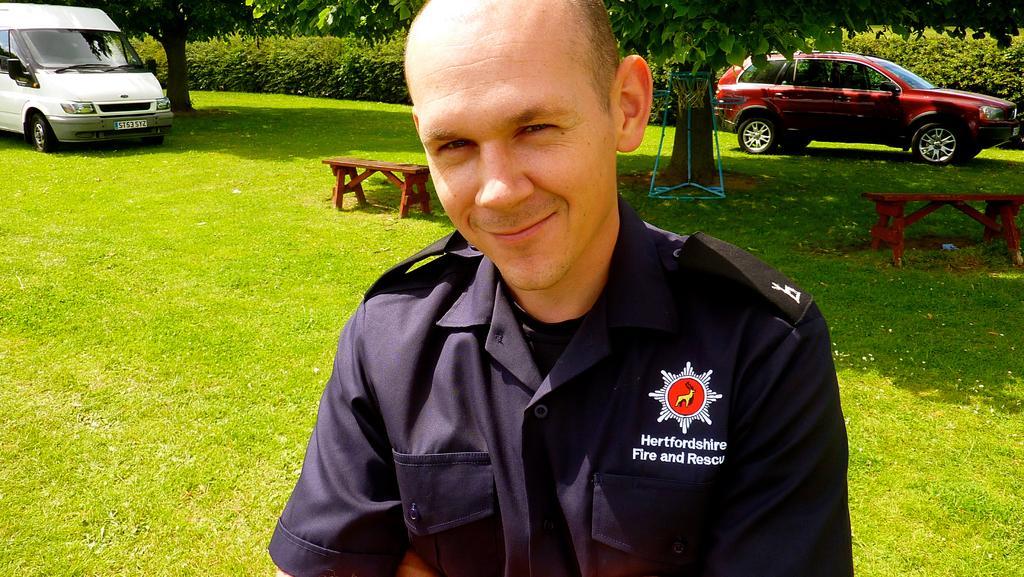Describe this image in one or two sentences. In the picture we can see a man who is smiling. In the background we can find some trees, car, van and two benches on the grass. The man who is smiling has worn uniform. 